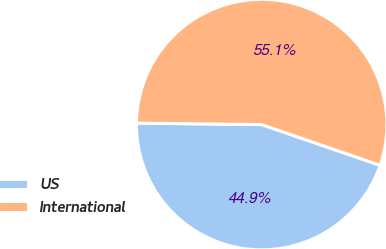Convert chart to OTSL. <chart><loc_0><loc_0><loc_500><loc_500><pie_chart><fcel>US<fcel>International<nl><fcel>44.92%<fcel>55.08%<nl></chart> 